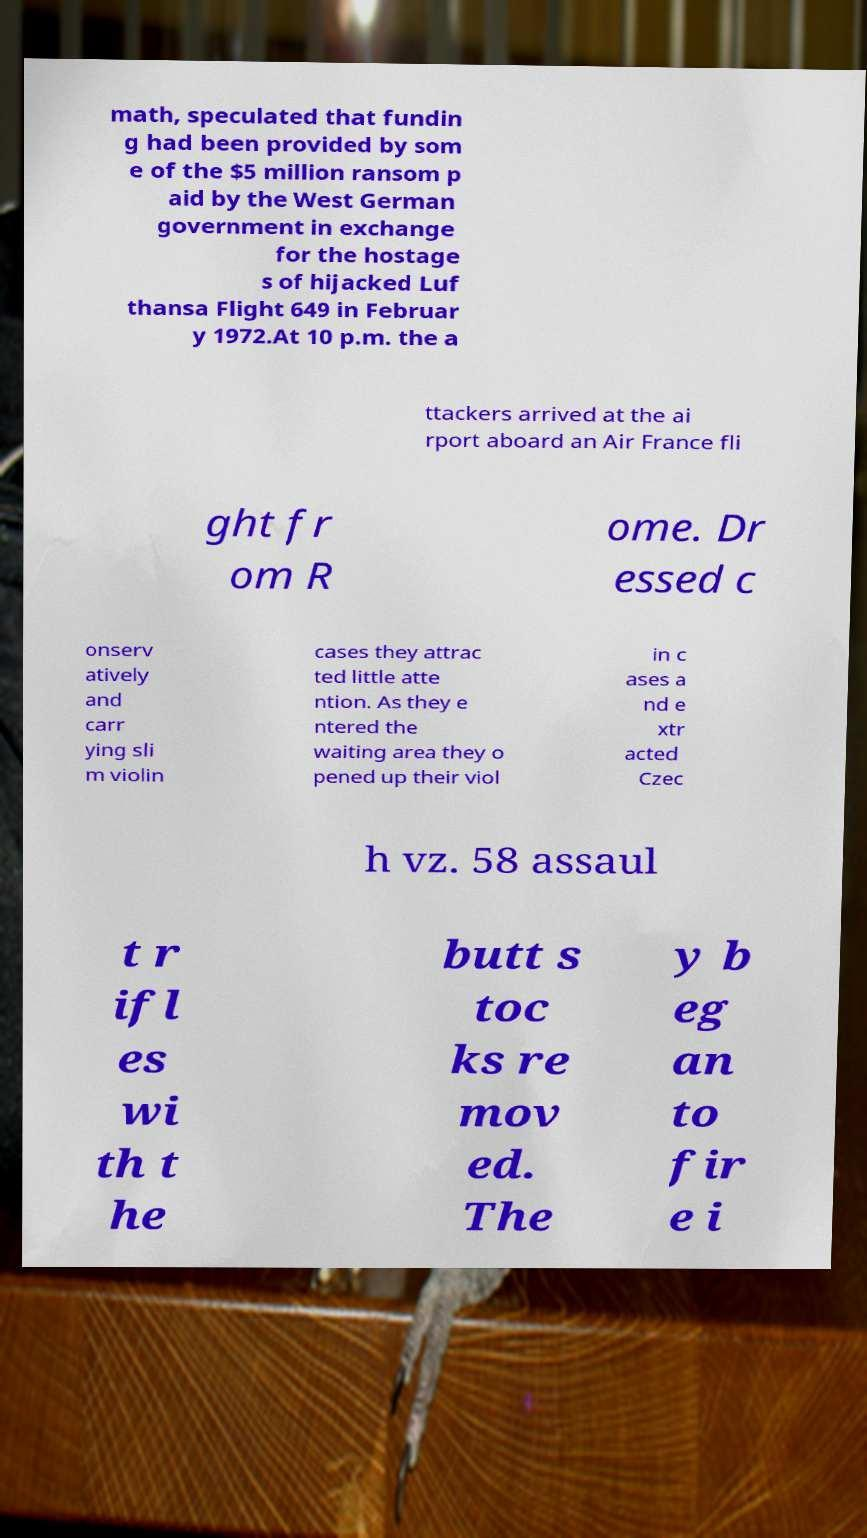Could you assist in decoding the text presented in this image and type it out clearly? math, speculated that fundin g had been provided by som e of the $5 million ransom p aid by the West German government in exchange for the hostage s of hijacked Luf thansa Flight 649 in Februar y 1972.At 10 p.m. the a ttackers arrived at the ai rport aboard an Air France fli ght fr om R ome. Dr essed c onserv atively and carr ying sli m violin cases they attrac ted little atte ntion. As they e ntered the waiting area they o pened up their viol in c ases a nd e xtr acted Czec h vz. 58 assaul t r ifl es wi th t he butt s toc ks re mov ed. The y b eg an to fir e i 